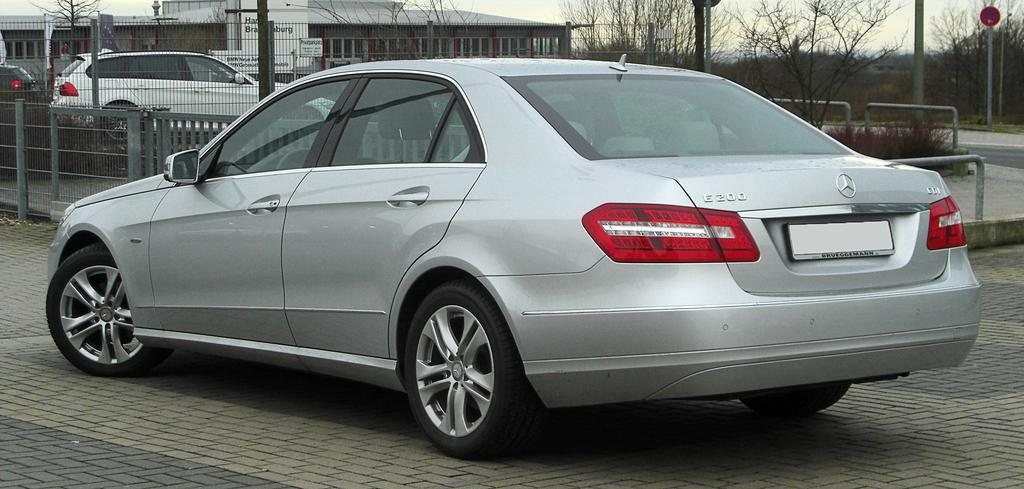What type of structure is present in the image? There is a building in the image. What can be seen parked near the building? There are cars parked in the image. What type of natural elements are visible in the image? There are trees visible in the image. What is located on the sidewalk in the image? There is a sign board on the sidewalk in the image. What type of vertical structures can be seen in the image? There are poles in the image. Where is the yak sitting on its throne in the image? There is no yak or throne present in the image. 